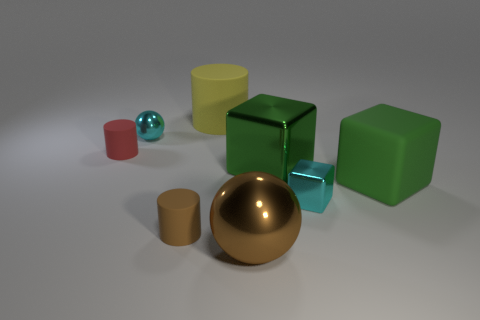Does the red cylinder have the same size as the yellow rubber cylinder?
Make the answer very short. No. There is a metal ball that is the same color as the small shiny block; what size is it?
Your answer should be very brief. Small. What is the size of the other green thing that is the same shape as the big green rubber object?
Give a very brief answer. Large. What size is the rubber thing that is on the right side of the small brown cylinder and in front of the yellow cylinder?
Ensure brevity in your answer.  Large. Do the red thing and the small cyan thing that is left of the large metal sphere have the same shape?
Provide a succinct answer. No. What number of things are either small cylinders in front of the cyan cube or matte cylinders?
Ensure brevity in your answer.  3. Are the big cylinder and the tiny cyan thing behind the red cylinder made of the same material?
Ensure brevity in your answer.  No. There is a small cyan object in front of the small rubber cylinder behind the big green rubber block; what shape is it?
Provide a succinct answer. Cube. Do the large metal block and the large matte block to the right of the small brown object have the same color?
Your response must be concise. Yes. What is the shape of the big green matte thing?
Offer a very short reply. Cube. 